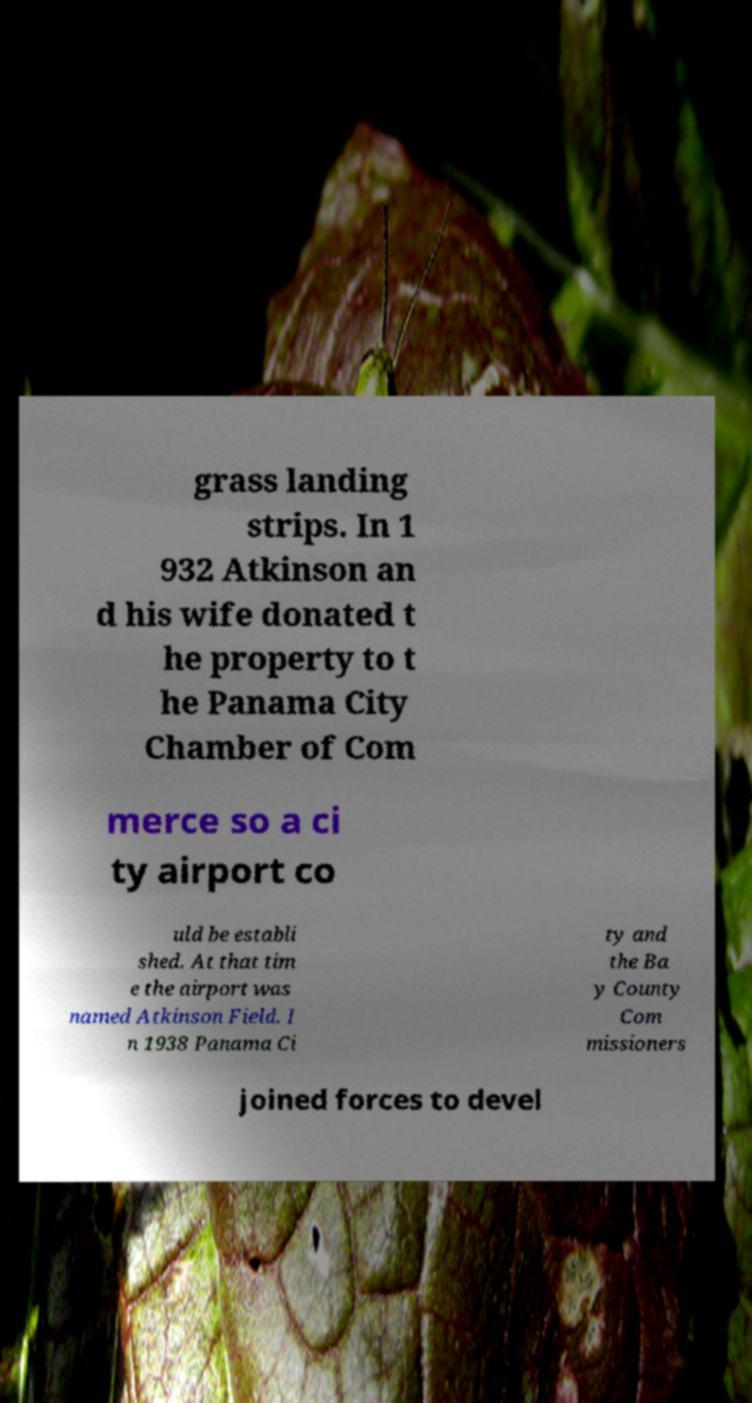I need the written content from this picture converted into text. Can you do that? grass landing strips. In 1 932 Atkinson an d his wife donated t he property to t he Panama City Chamber of Com merce so a ci ty airport co uld be establi shed. At that tim e the airport was named Atkinson Field. I n 1938 Panama Ci ty and the Ba y County Com missioners joined forces to devel 